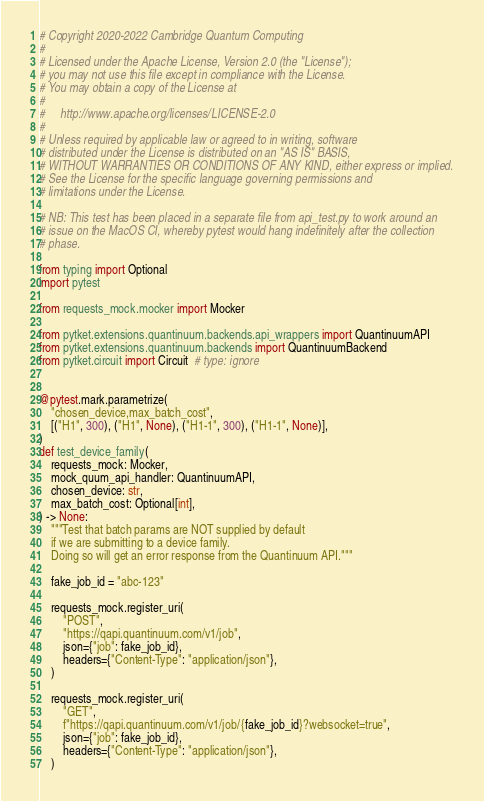<code> <loc_0><loc_0><loc_500><loc_500><_Python_># Copyright 2020-2022 Cambridge Quantum Computing
#
# Licensed under the Apache License, Version 2.0 (the "License");
# you may not use this file except in compliance with the License.
# You may obtain a copy of the License at
#
#     http://www.apache.org/licenses/LICENSE-2.0
#
# Unless required by applicable law or agreed to in writing, software
# distributed under the License is distributed on an "AS IS" BASIS,
# WITHOUT WARRANTIES OR CONDITIONS OF ANY KIND, either express or implied.
# See the License for the specific language governing permissions and
# limitations under the License.

# NB: This test has been placed in a separate file from api_test.py to work around an
# issue on the MacOS CI, whereby pytest would hang indefinitely after the collection
# phase.

from typing import Optional
import pytest

from requests_mock.mocker import Mocker

from pytket.extensions.quantinuum.backends.api_wrappers import QuantinuumAPI
from pytket.extensions.quantinuum.backends import QuantinuumBackend
from pytket.circuit import Circuit  # type: ignore


@pytest.mark.parametrize(
    "chosen_device,max_batch_cost",
    [("H1", 300), ("H1", None), ("H1-1", 300), ("H1-1", None)],
)
def test_device_family(
    requests_mock: Mocker,
    mock_quum_api_handler: QuantinuumAPI,
    chosen_device: str,
    max_batch_cost: Optional[int],
) -> None:
    """Test that batch params are NOT supplied by default
    if we are submitting to a device family.
    Doing so will get an error response from the Quantinuum API."""

    fake_job_id = "abc-123"

    requests_mock.register_uri(
        "POST",
        "https://qapi.quantinuum.com/v1/job",
        json={"job": fake_job_id},
        headers={"Content-Type": "application/json"},
    )

    requests_mock.register_uri(
        "GET",
        f"https://qapi.quantinuum.com/v1/job/{fake_job_id}?websocket=true",
        json={"job": fake_job_id},
        headers={"Content-Type": "application/json"},
    )
</code> 